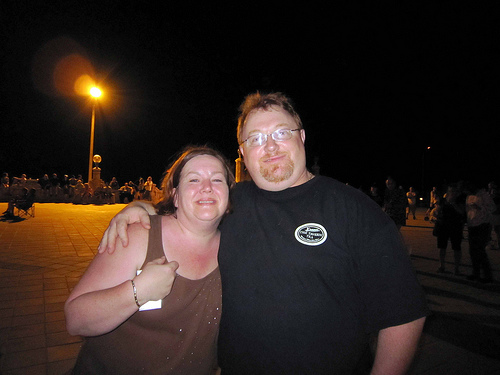<image>
Is the man on the women? No. The man is not positioned on the women. They may be near each other, but the man is not supported by or resting on top of the women. 